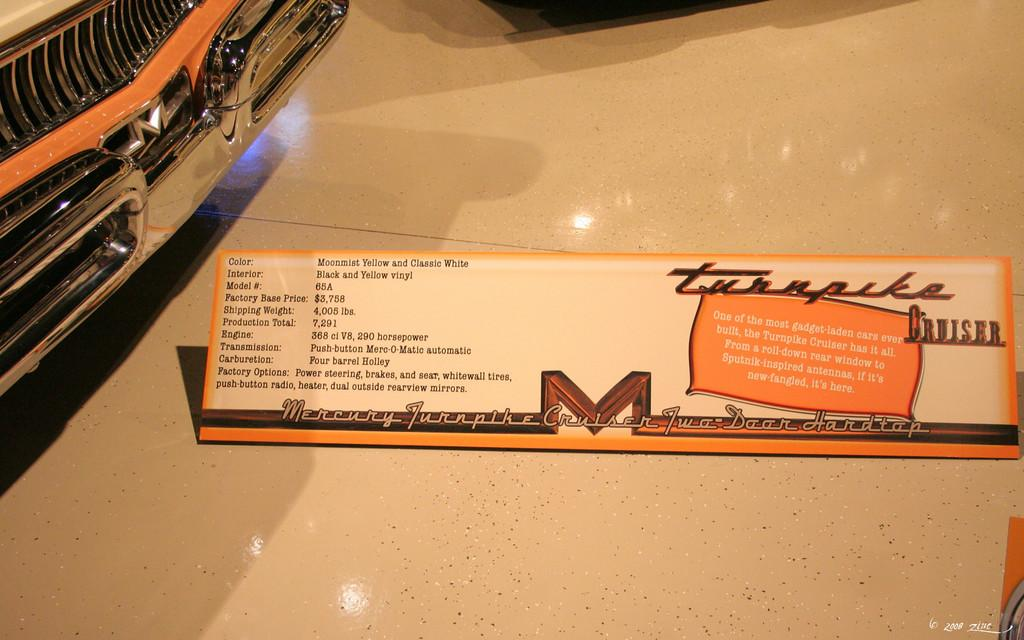What is located on the floor in the image? There is a board on the floor in the image. Where is the board positioned in the image? The board is in the middle of the image. What else can be seen in the image besides the board? There appears to be a car in the top left corner of the image. What is the name of the person skateboarding on the board in the image? There is no person skateboarding on the board in the image; it is simply a board on the floor. What trick is the person performing on the board in the image? There is no person performing any tricks on the board in the image; it is just a stationary board on the floor. 